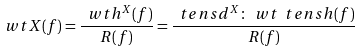<formula> <loc_0><loc_0><loc_500><loc_500>\ w t { X } ( f ) = \frac { \ w t { h } ^ { X } ( f ) } { R ( f ) } = \frac { \ t e n s { d } ^ { X } \colon \ w t { \ t e n s { h } } ( f ) } { R ( f ) }</formula> 